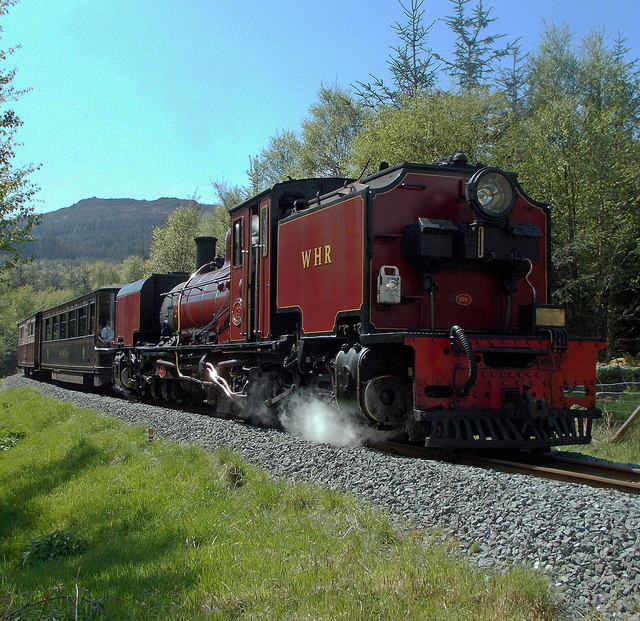Identify the text contained in this image. WHR 